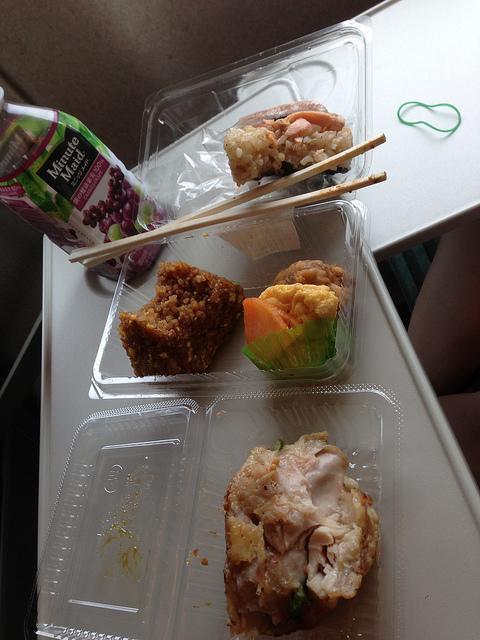How many bears are in this picture?
Give a very brief answer. 0. 